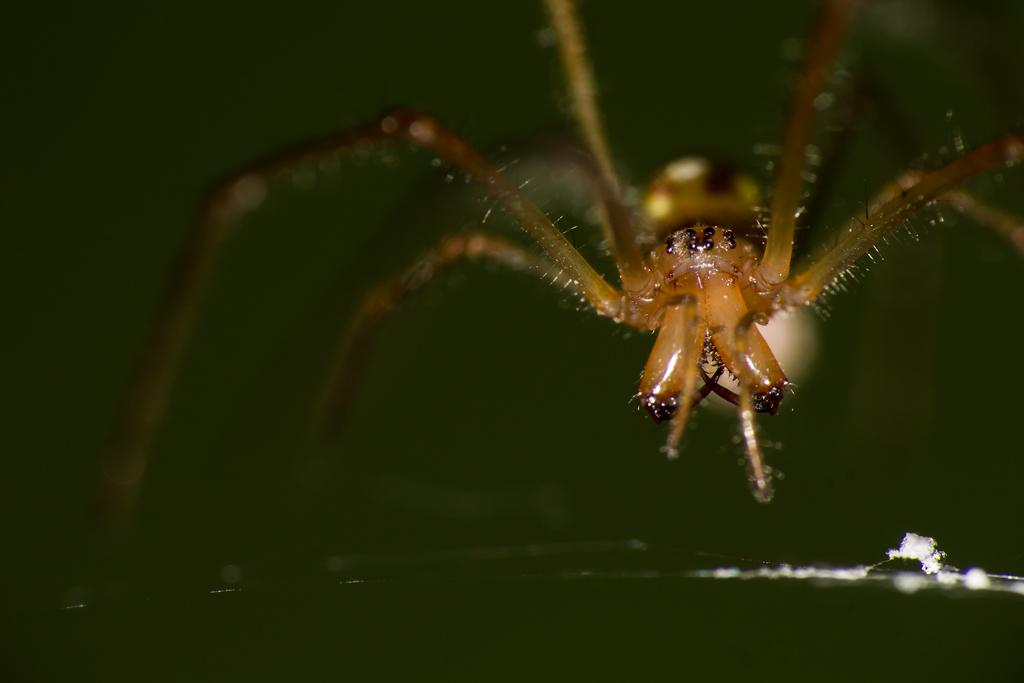What type of creature is present in the image? There is an insect in the image. What type of juice can be seen in the image? There is no juice present in the image; it only features an insect. How does the insect react to the pest in the image? There is no mention of a pest in the image, so it cannot be determined how the insect would react. 